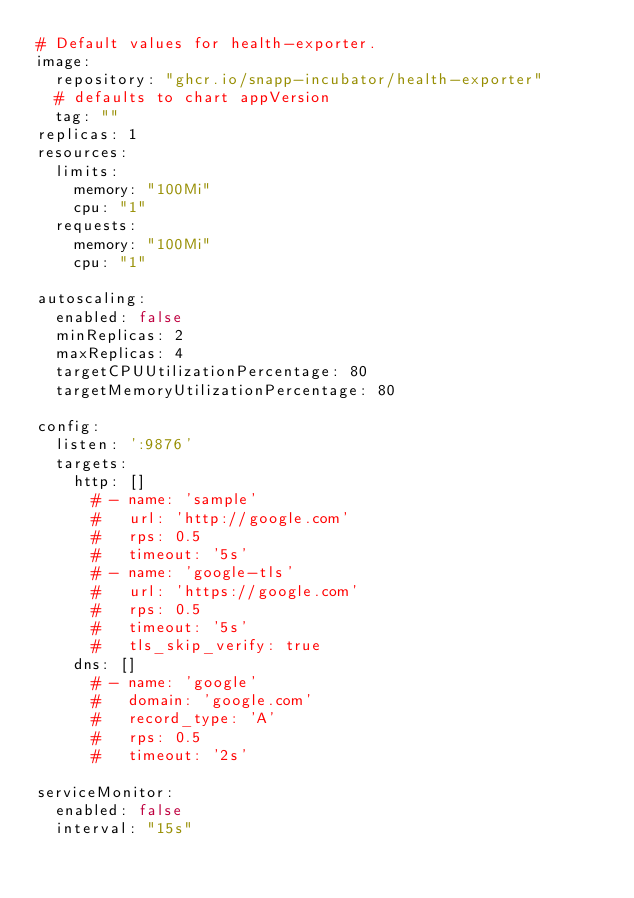<code> <loc_0><loc_0><loc_500><loc_500><_YAML_># Default values for health-exporter.
image:
  repository: "ghcr.io/snapp-incubator/health-exporter"
  # defaults to chart appVersion
  tag: ""
replicas: 1
resources:
  limits:
    memory: "100Mi"
    cpu: "1"
  requests:
    memory: "100Mi"
    cpu: "1"

autoscaling:
  enabled: false
  minReplicas: 2
  maxReplicas: 4
  targetCPUUtilizationPercentage: 80
  targetMemoryUtilizationPercentage: 80

config:
  listen: ':9876'
  targets:
    http: []
      # - name: 'sample'
      #   url: 'http://google.com'
      #   rps: 0.5
      #   timeout: '5s'
      # - name: 'google-tls'
      #   url: 'https://google.com'
      #   rps: 0.5
      #   timeout: '5s'
      #   tls_skip_verify: true
    dns: []
      # - name: 'google'
      #   domain: 'google.com'
      #   record_type: 'A'
      #   rps: 0.5
      #   timeout: '2s'
      
serviceMonitor:
  enabled: false
  interval: "15s"
</code> 